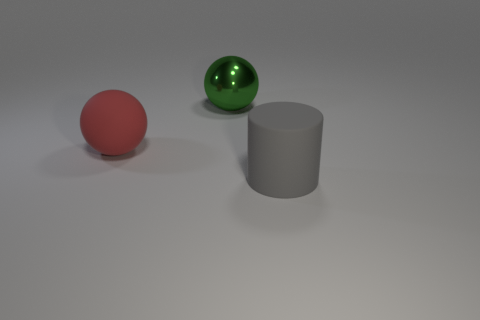There is a shiny object; does it have the same shape as the big matte object that is right of the red rubber ball?
Keep it short and to the point. No. Are there any matte balls right of the big red rubber thing?
Your answer should be very brief. No. What number of blocks are green rubber objects or matte objects?
Ensure brevity in your answer.  0. Is the large red matte thing the same shape as the large gray rubber object?
Give a very brief answer. No. There is a shiny object that is on the right side of the red rubber ball; how big is it?
Make the answer very short. Large. Are there any large rubber things that have the same color as the large shiny ball?
Provide a succinct answer. No. There is a sphere that is on the right side of the rubber ball; does it have the same size as the rubber sphere?
Ensure brevity in your answer.  Yes. What is the color of the shiny sphere?
Make the answer very short. Green. There is a large rubber thing right of the large ball behind the red sphere; what color is it?
Ensure brevity in your answer.  Gray. Is there a large sphere that has the same material as the large green thing?
Offer a very short reply. No. 